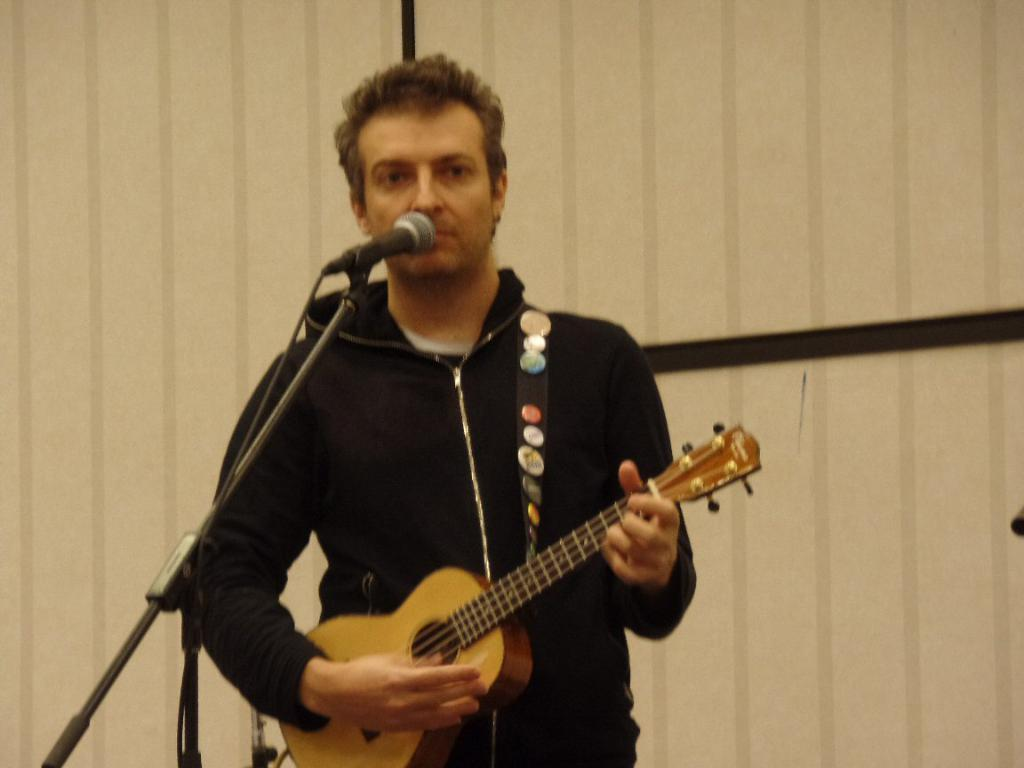What is the main subject of the image? There is a person in the image. What is the person doing in the image? The person is standing in front of a mic and holding a guitar. What can be seen in the background of the image? There is a wall in the background of the image. What type of fowl can be seen perched on the guitar in the image? There is no fowl present in the image, and the guitar is not being used as a perch. 